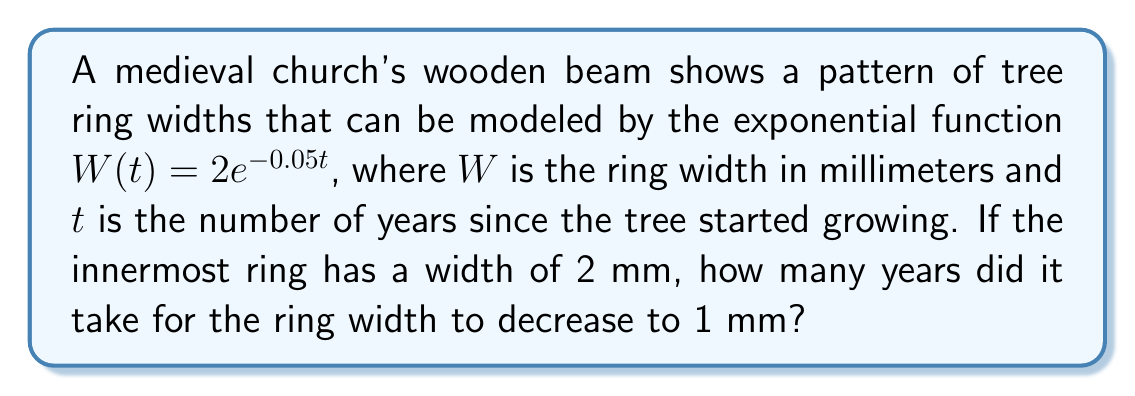Solve this math problem. To solve this problem, we need to use the given exponential function and determine the time $t$ when the width $W(t)$ equals 1 mm. Let's approach this step-by-step:

1) We start with the exponential function:
   $W(t) = 2e^{-0.05t}$

2) We want to find $t$ when $W(t) = 1$, so we set up the equation:
   $1 = 2e^{-0.05t}$

3) Divide both sides by 2:
   $\frac{1}{2} = e^{-0.05t}$

4) Take the natural logarithm of both sides:
   $\ln(\frac{1}{2}) = \ln(e^{-0.05t})$

5) Simplify the right side using the properties of logarithms:
   $\ln(\frac{1}{2}) = -0.05t$

6) Solve for $t$:
   $t = -\frac{\ln(\frac{1}{2})}{0.05}$

7) Simplify:
   $t = -\frac{\ln(0.5)}{0.05} \approx 13.86$

8) Since we're dealing with whole years, we round to the nearest integer:
   $t \approx 14$ years

Therefore, it took approximately 14 years for the ring width to decrease from 2 mm to 1 mm.
Answer: 14 years 